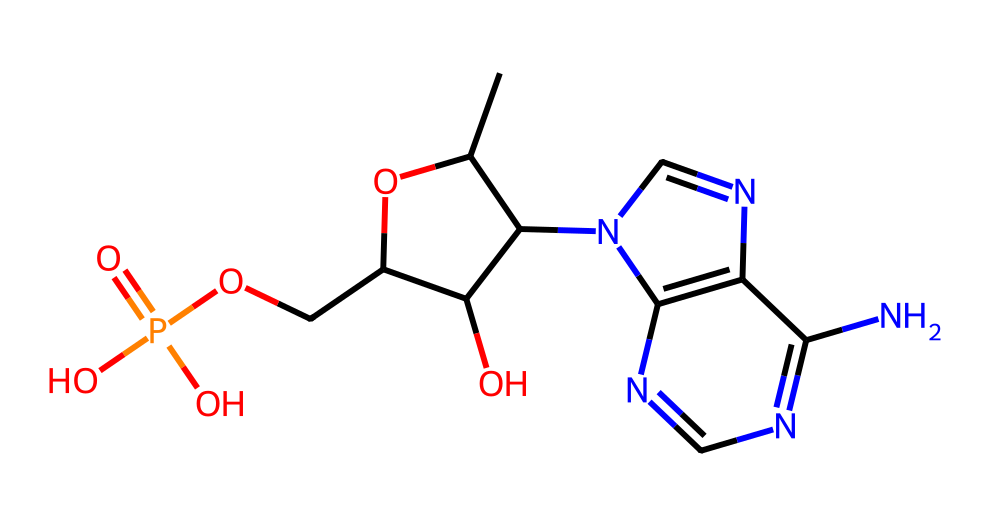What is the molecular formula of this compound? To determine the molecular formula, I need to count the number of carbon (C), hydrogen (H), nitrogen (N), oxygen (O), and phosphorus (P) atoms from the SMILES representation. From the structure, I can see there are 10 carbon, 13 hydrogen, 5 nitrogen, 4 oxygen, and 1 phosphorus atom. Thus, the molecular formula is C10H13N5O4P.
Answer: C10H13N5O4P How many rings are present in this chemical structure? By examining the SMILES, I can identify the cyclic structures. The notation reveals two ring structures: one with 5 members (the ribose part) and another with 5 members (the nitrogen base). Therefore, there are two rings total.
Answer: 2 What type of biological molecule is represented by this structure? This structure represents nucleotides, which are the basic building blocks of nucleic acids like DNA. The presence of ribose, nitrogenous bases (N), and a phosphate group indicates it is a nucleotide.
Answer: nucleotide How many nitrogen atoms are in the molecule? Looking closely at the SMILES, I can count the nitrogen (N) atoms present in the structure. There are 5 nitrogen atoms in total.
Answer: 5 What specific type of bond connects the phosphate group to the sugar? The bond connecting the phosphate group to the sugar is a phosphoester bond. In the compound, this can be identified where the phosphate is attached to the ribose sugar, forming the backbone of the DNA molecule.
Answer: phosphoester Which part of this structure indicates it is a component of DNA? The presence of the deoxyribose sugar and the nitrogenous base is indicative of a DNA nucleotide. The specific arrangement and components suggest it is indeed part of the DNA structure.
Answer: deoxyribose sugar and nitrogenous base 